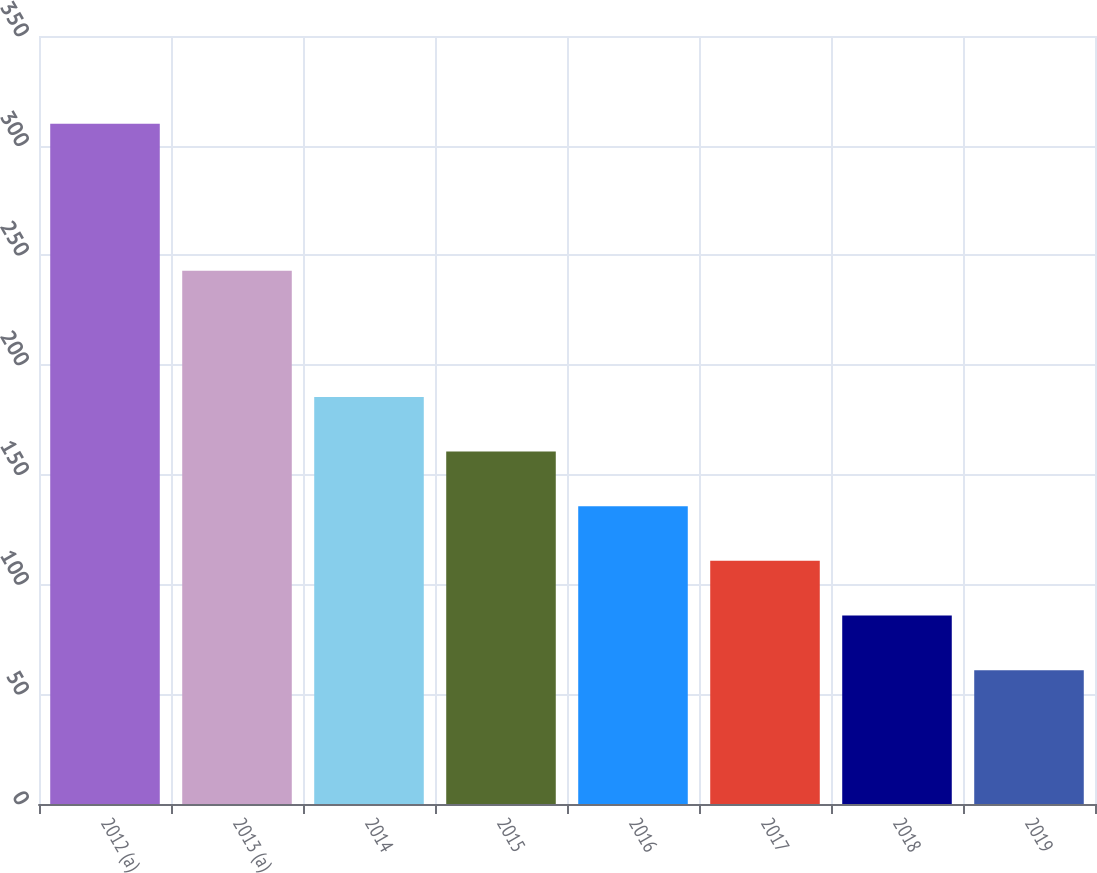<chart> <loc_0><loc_0><loc_500><loc_500><bar_chart><fcel>2012 (a)<fcel>2013 (a)<fcel>2014<fcel>2015<fcel>2016<fcel>2017<fcel>2018<fcel>2019<nl><fcel>310<fcel>243<fcel>185.5<fcel>160.6<fcel>135.7<fcel>110.8<fcel>85.9<fcel>61<nl></chart> 